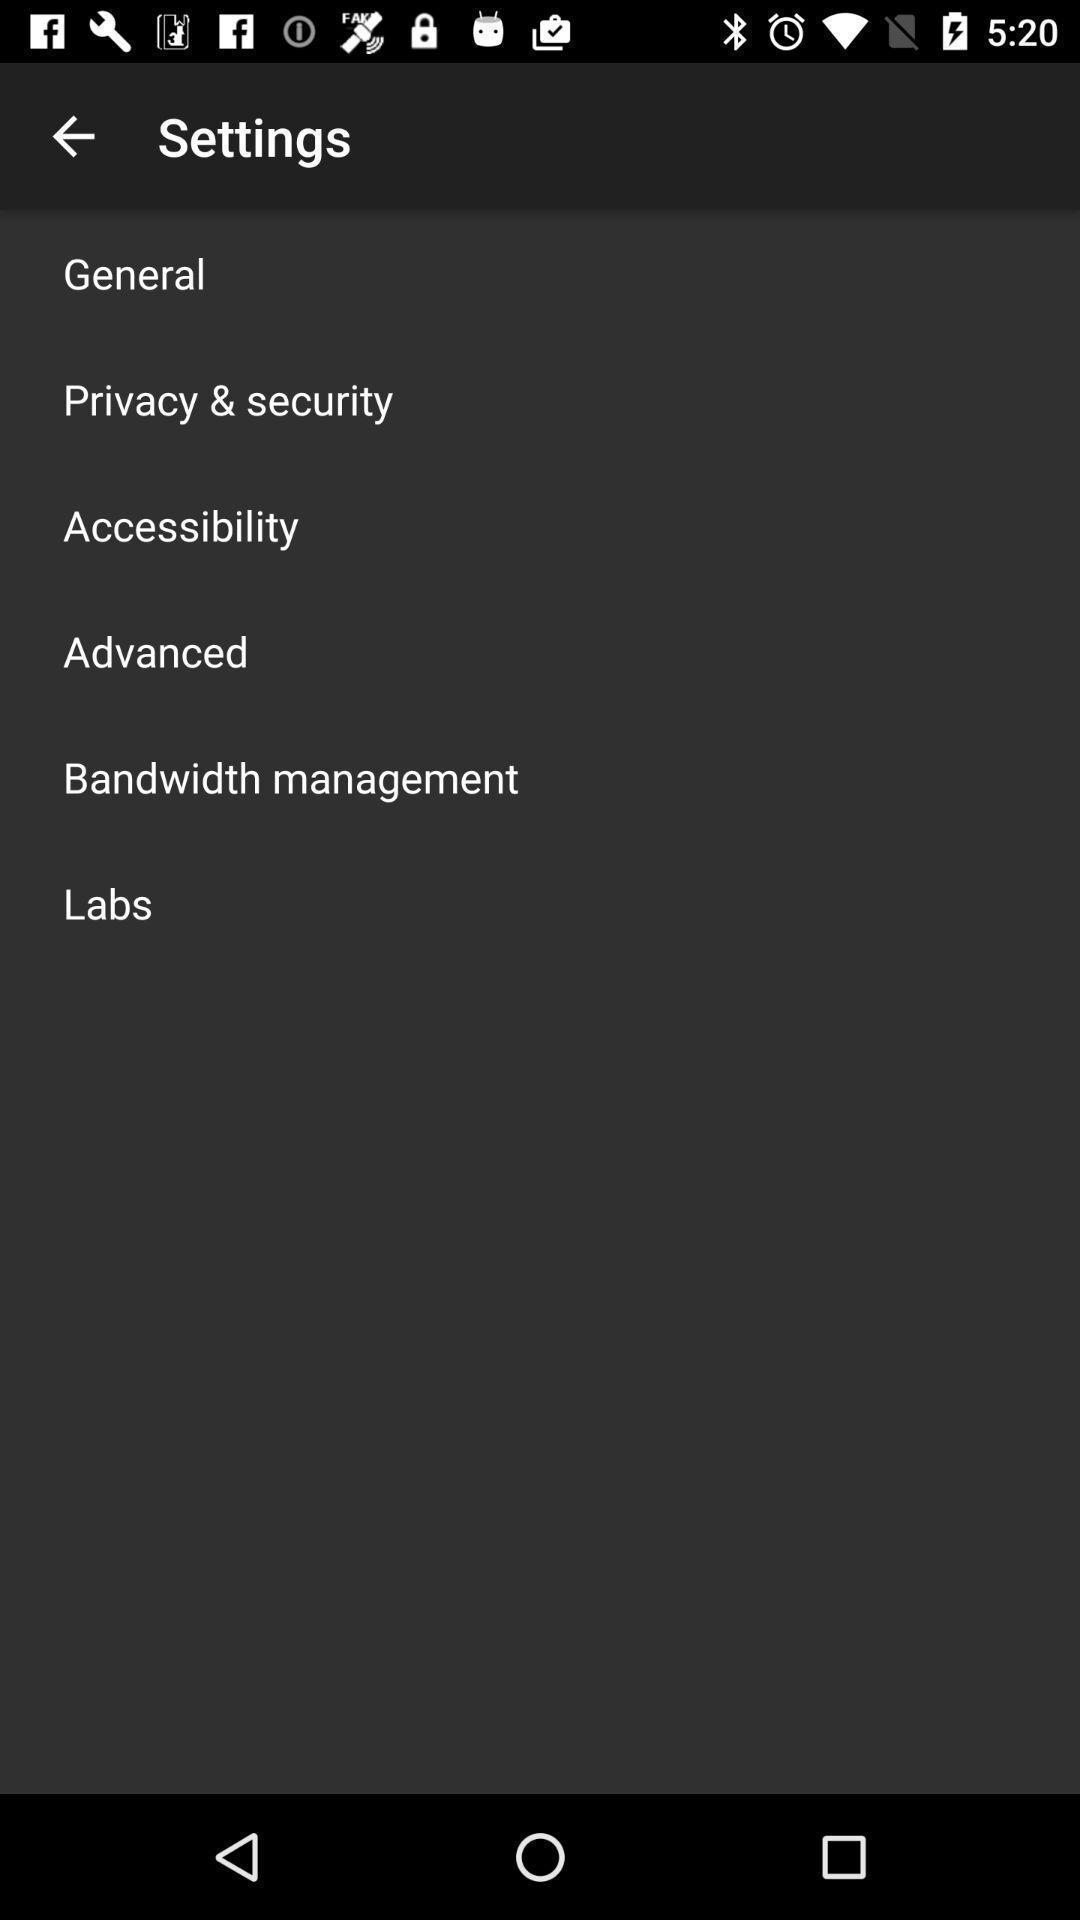Summarize the main components in this picture. Window displaying the settings page. 